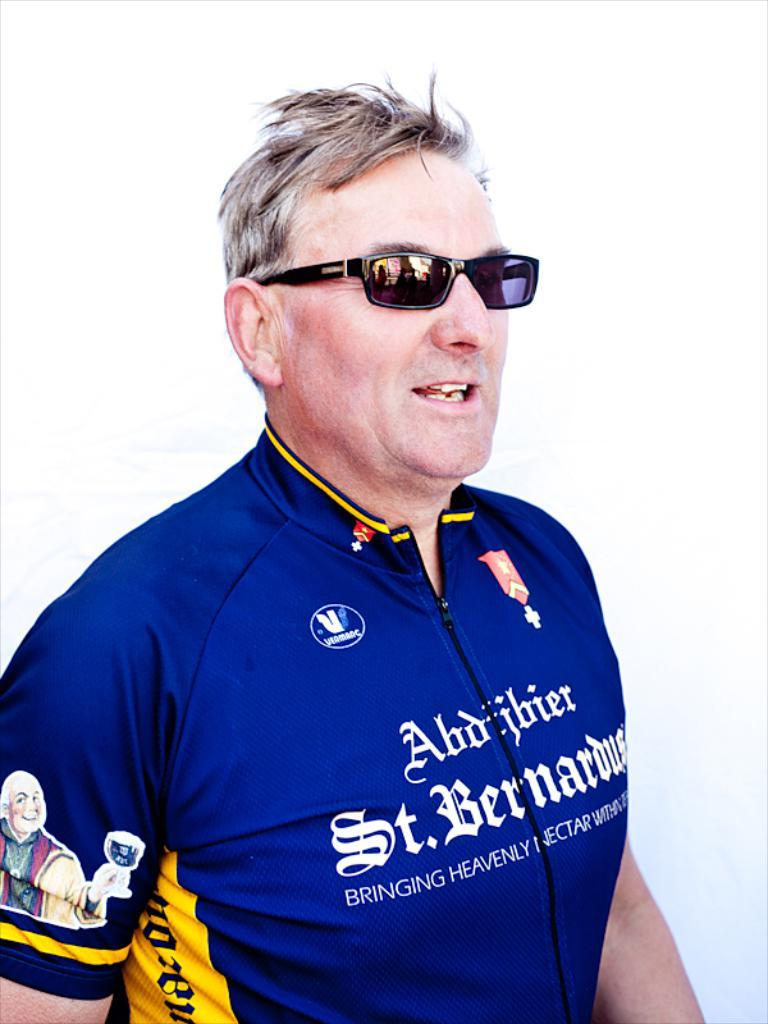Provide a one-sentence caption for the provided image. A man wearing a shirt with St. Bernardus across the front. 